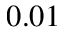Convert formula to latex. <formula><loc_0><loc_0><loc_500><loc_500>0 . 0 1</formula> 